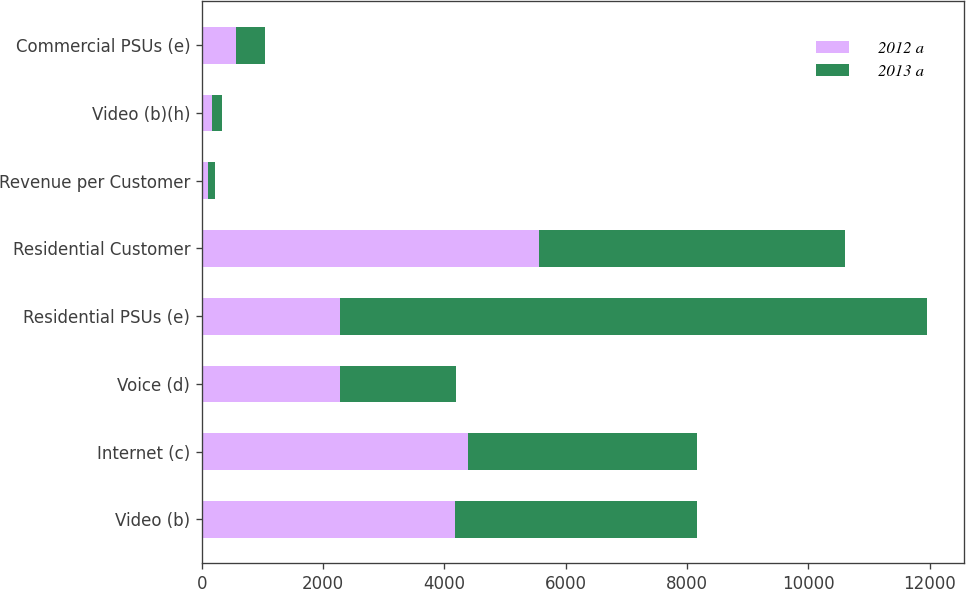<chart> <loc_0><loc_0><loc_500><loc_500><stacked_bar_chart><ecel><fcel>Video (b)<fcel>Internet (c)<fcel>Voice (d)<fcel>Residential PSUs (e)<fcel>Residential Customer<fcel>Revenue per Customer<fcel>Video (b)(h)<fcel>Commercial PSUs (e)<nl><fcel>2012 a<fcel>4177<fcel>4383<fcel>2273<fcel>2273<fcel>5561<fcel>107.97<fcel>165<fcel>567<nl><fcel>2013 a<fcel>3989<fcel>3785<fcel>1914<fcel>9688<fcel>5035<fcel>105.78<fcel>169<fcel>467<nl></chart> 